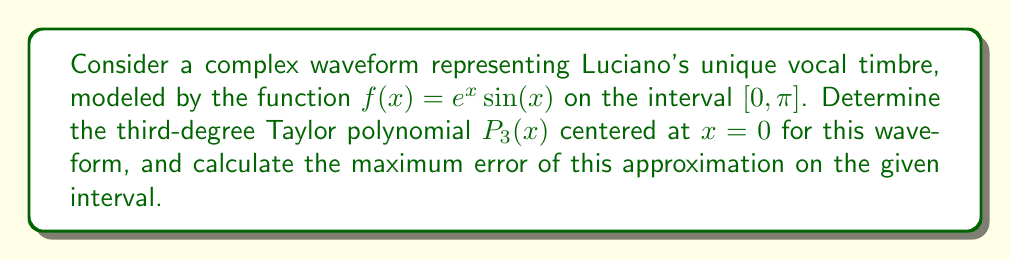Provide a solution to this math problem. 1) First, we need to find the Taylor series expansion of $f(x) = e^x \sin(x)$ up to the third degree. The general formula for the Taylor series is:

   $$P_n(x) = f(0) + f'(0)x + \frac{f''(0)}{2!}x^2 + \frac{f'''(0)}{3!}x^3 + \cdots + \frac{f^{(n)}(0)}{n!}x^n$$

2) Let's calculate the derivatives and their values at $x = 0$:

   $f(x) = e^x \sin(x)$
   $f(0) = 0$

   $f'(x) = e^x \sin(x) + e^x \cos(x)$
   $f'(0) = 1$

   $f''(x) = e^x \sin(x) + 2e^x \cos(x) - e^x \sin(x) = 2e^x \cos(x)$
   $f''(0) = 2$

   $f'''(x) = 2e^x \cos(x) - 2e^x \sin(x) = 2e^x (\cos(x) - \sin(x))$
   $f'''(0) = 2$

3) Now we can construct the third-degree Taylor polynomial:

   $$P_3(x) = 0 + x + \frac{2}{2!}x^2 + \frac{2}{3!}x^3 = x + x^2 + \frac{1}{3}x^3$$

4) To find the maximum error, we need to use the error bound formula for Taylor polynomials:

   $$|R_n(x)| \leq \frac{M}{(n+1)!}|x-a|^{n+1}$$

   where $M$ is the maximum value of $|f^{(n+1)}(x)|$ on the interval.

5) In our case, $n = 3$, $a = 0$, and the interval is $[0, \pi]$. We need to find $M = \max|f^{(4)}(x)|$ on $[0, \pi]$.

   $f^{(4)}(x) = 2e^x (\cos(x) - \sin(x)) - 2e^x (\cos(x) - \sin(x)) = 0$

6) Since $f^{(4)}(x) = 0$, the error is actually zero, meaning our third-degree polynomial is exact!

7) Therefore, the maximum error on $[0, \pi]$ is 0.
Answer: $P_3(x) = x + x^2 + \frac{1}{3}x^3$; Maximum error = 0 